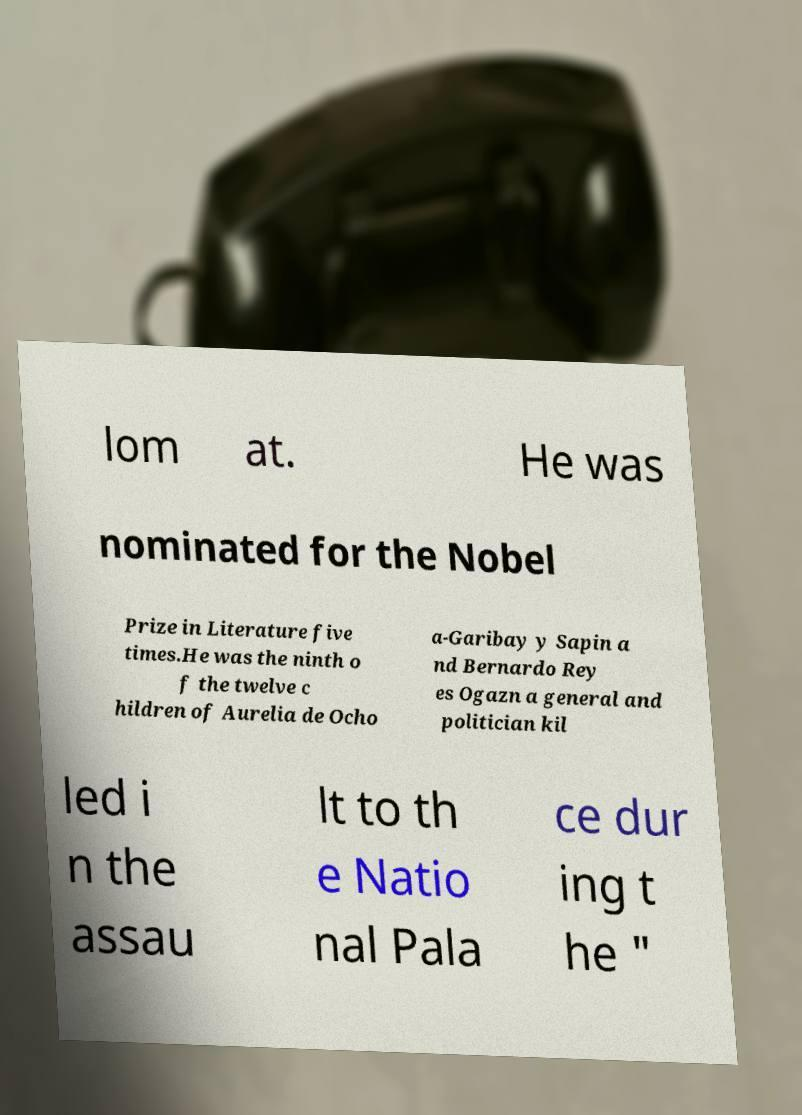For documentation purposes, I need the text within this image transcribed. Could you provide that? lom at. He was nominated for the Nobel Prize in Literature five times.He was the ninth o f the twelve c hildren of Aurelia de Ocho a-Garibay y Sapin a nd Bernardo Rey es Ogazn a general and politician kil led i n the assau lt to th e Natio nal Pala ce dur ing t he " 